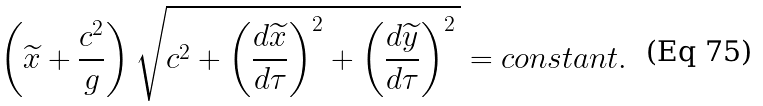<formula> <loc_0><loc_0><loc_500><loc_500>\left ( \widetilde { x } + \frac { c ^ { 2 } } { g } \right ) \sqrt { c ^ { 2 } + \left ( \frac { d \widetilde { x } } { d \tau } \right ) ^ { 2 } + \left ( \frac { d \widetilde { y } } { d \tau } \right ) ^ { 2 } \, } = c o n s t a n t .</formula> 